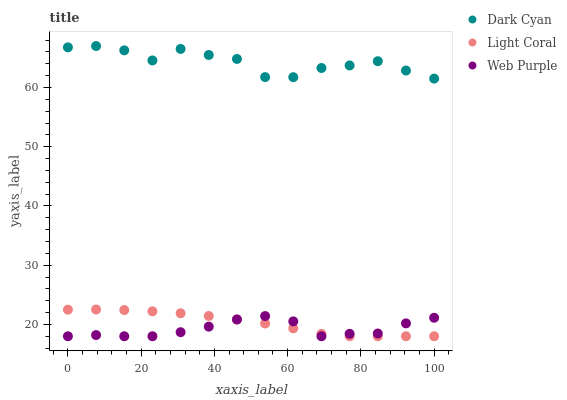Does Web Purple have the minimum area under the curve?
Answer yes or no. Yes. Does Dark Cyan have the maximum area under the curve?
Answer yes or no. Yes. Does Light Coral have the minimum area under the curve?
Answer yes or no. No. Does Light Coral have the maximum area under the curve?
Answer yes or no. No. Is Light Coral the smoothest?
Answer yes or no. Yes. Is Dark Cyan the roughest?
Answer yes or no. Yes. Is Web Purple the smoothest?
Answer yes or no. No. Is Web Purple the roughest?
Answer yes or no. No. Does Light Coral have the lowest value?
Answer yes or no. Yes. Does Dark Cyan have the highest value?
Answer yes or no. Yes. Does Light Coral have the highest value?
Answer yes or no. No. Is Web Purple less than Dark Cyan?
Answer yes or no. Yes. Is Dark Cyan greater than Web Purple?
Answer yes or no. Yes. Does Light Coral intersect Web Purple?
Answer yes or no. Yes. Is Light Coral less than Web Purple?
Answer yes or no. No. Is Light Coral greater than Web Purple?
Answer yes or no. No. Does Web Purple intersect Dark Cyan?
Answer yes or no. No. 